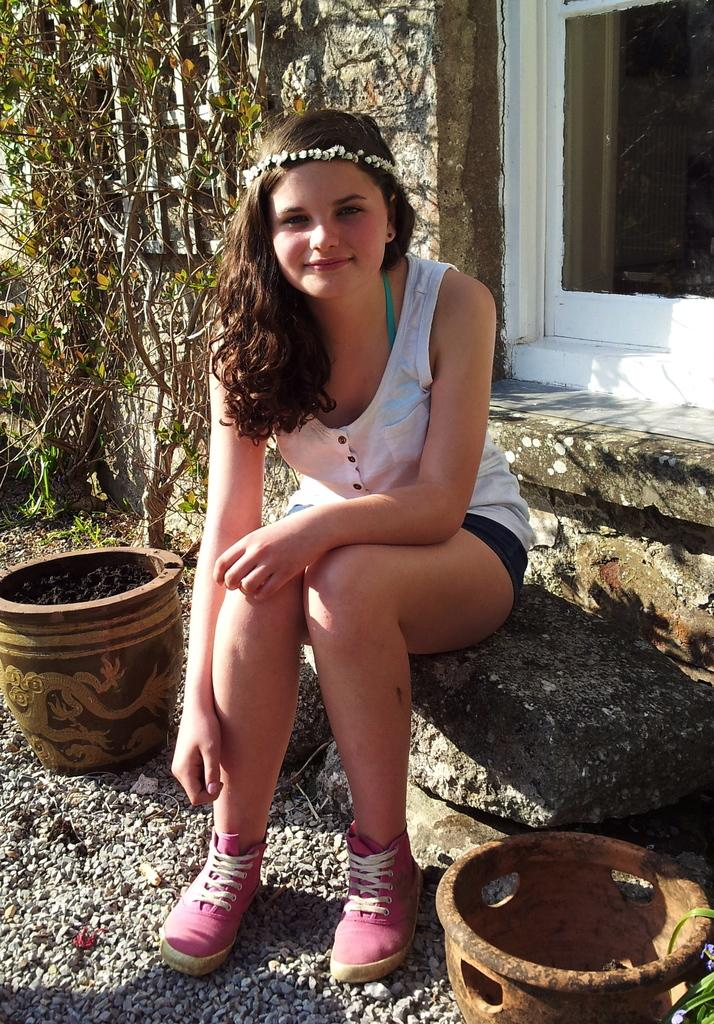What can be seen in the background of the image? There is a wall and a window in the background of the image. What is the woman in the image doing? The woman is sitting on a rock surface in the image. What is the woman's expression in the image? The woman is smiling in the image. What objects are present in the image? There are pots, stones, and plants in the image. Can you tell me the story behind the zebra in the image? There is no zebra present in the image, so there is no story to tell about it. What type of beetle can be seen crawling on the plants in the image? There are no beetles visible in the image; only the woman, rock surface, pots, stones, and plants can be seen. 